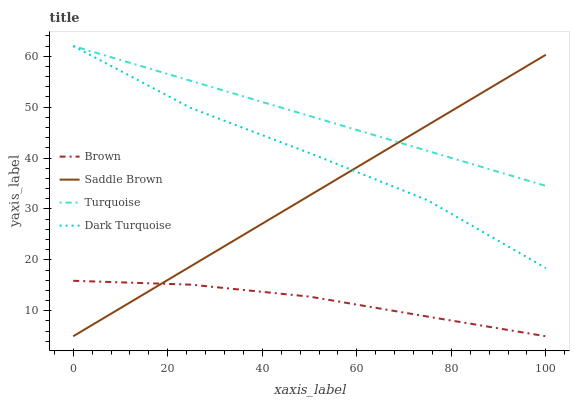Does Brown have the minimum area under the curve?
Answer yes or no. Yes. Does Turquoise have the maximum area under the curve?
Answer yes or no. Yes. Does Saddle Brown have the minimum area under the curve?
Answer yes or no. No. Does Saddle Brown have the maximum area under the curve?
Answer yes or no. No. Is Turquoise the smoothest?
Answer yes or no. Yes. Is Dark Turquoise the roughest?
Answer yes or no. Yes. Is Saddle Brown the smoothest?
Answer yes or no. No. Is Saddle Brown the roughest?
Answer yes or no. No. Does Turquoise have the lowest value?
Answer yes or no. No. Does Dark Turquoise have the highest value?
Answer yes or no. Yes. Does Saddle Brown have the highest value?
Answer yes or no. No. Is Brown less than Dark Turquoise?
Answer yes or no. Yes. Is Turquoise greater than Brown?
Answer yes or no. Yes. Does Turquoise intersect Dark Turquoise?
Answer yes or no. Yes. Is Turquoise less than Dark Turquoise?
Answer yes or no. No. Is Turquoise greater than Dark Turquoise?
Answer yes or no. No. Does Brown intersect Dark Turquoise?
Answer yes or no. No. 